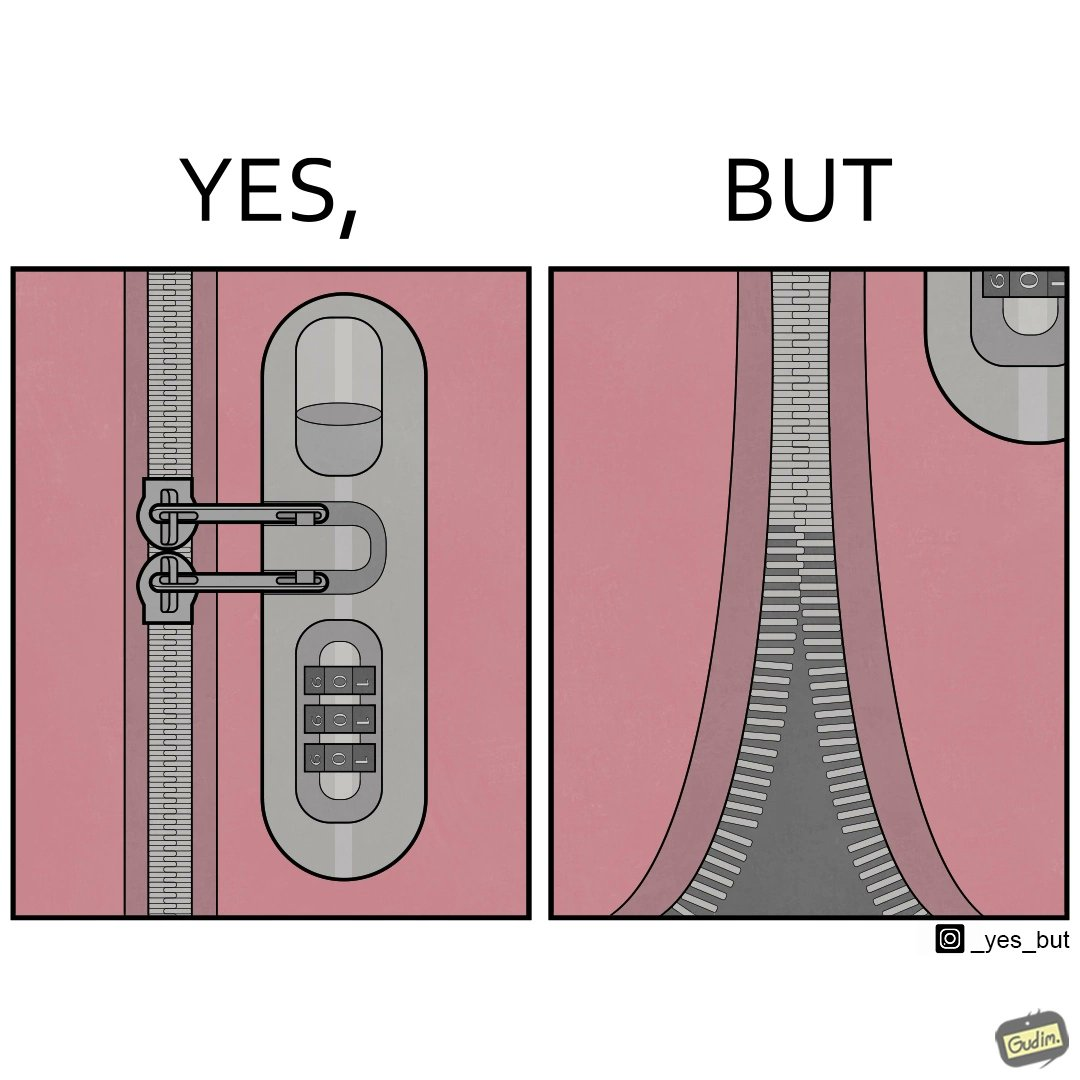Why is this image considered satirical? The images are funny since it shows how even though we use padlocks to keep our luggage safe on trolleys, it is rendered useless as the zip chain breaks anyways 